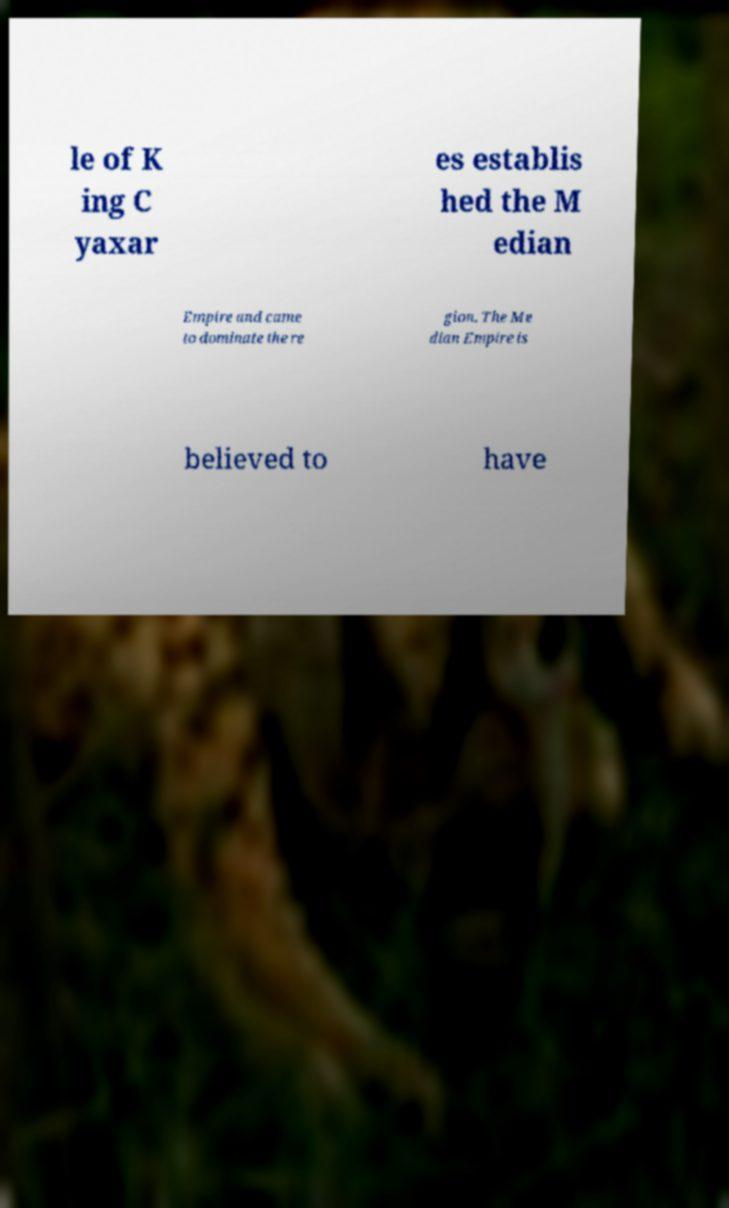Please identify and transcribe the text found in this image. le of K ing C yaxar es establis hed the M edian Empire and came to dominate the re gion. The Me dian Empire is believed to have 